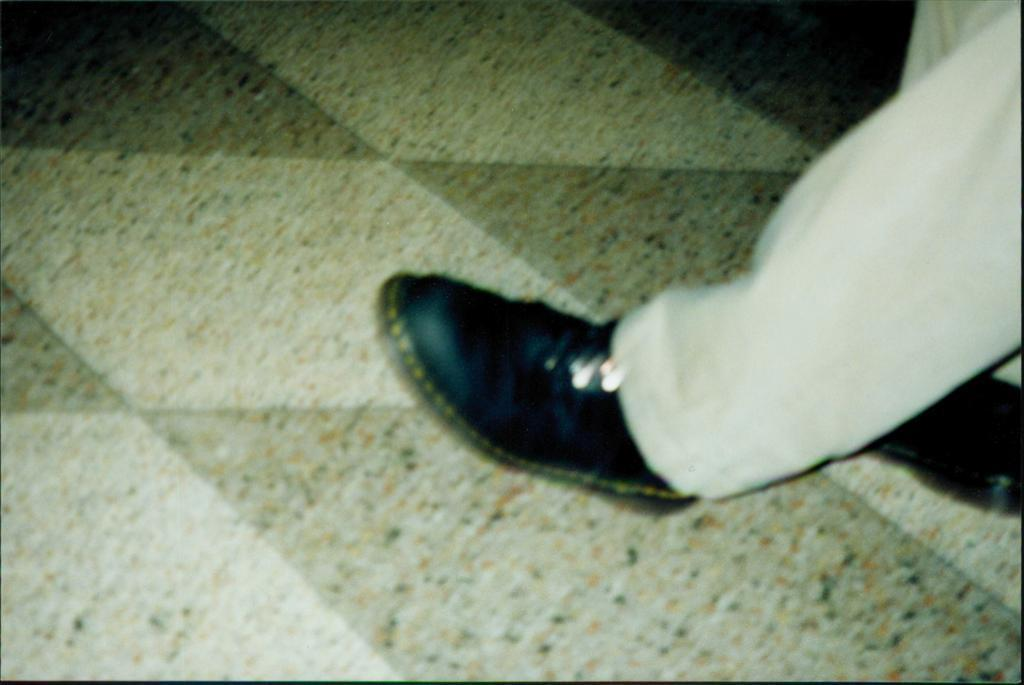What part of a person can be seen in the image? There is a leg of a person in the image. What is the person wearing on their foot? The person is wearing a shoe. What can be seen in the background of the image? The background of the image includes the floor. How many ladybugs are crawling on the person's leg in the image? There are no ladybugs present in the image. What is the condition of the person's leg in the image? The condition of the person's leg cannot be determined from the image. 